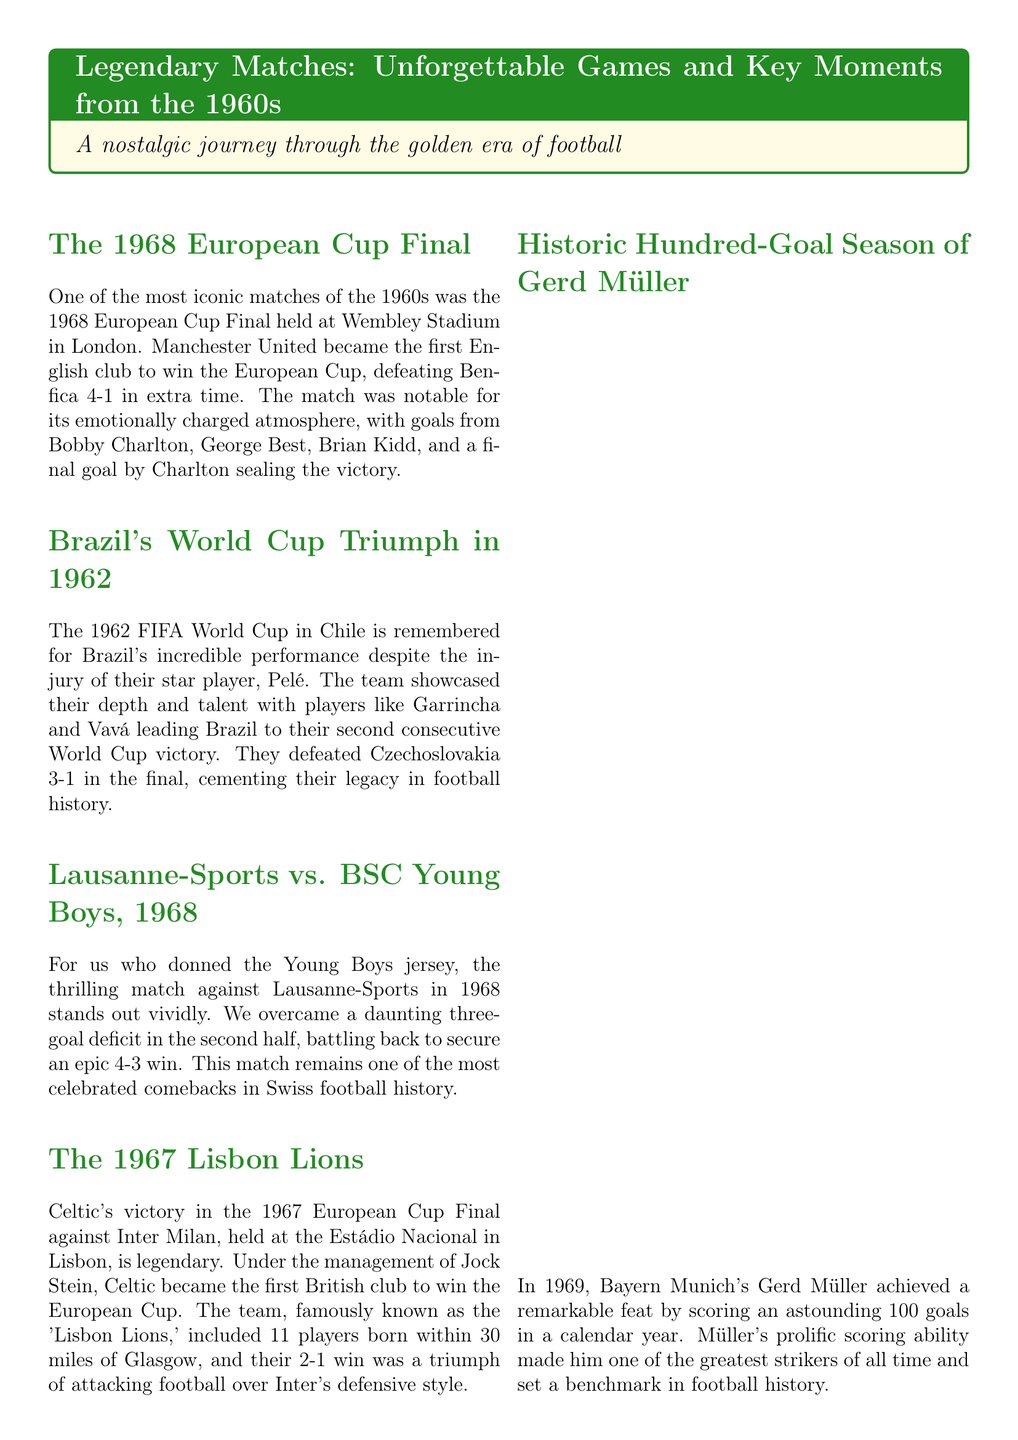What team won the 1968 European Cup Final? The document states that Manchester United won the 1968 European Cup Final against Benfica.
Answer: Manchester United What was the score of Brazil's World Cup final in 1962? Brazil won the final against Czechoslovakia with a score of 3-1.
Answer: 3-1 Who scored the final goal for Manchester United in the 1968 European Cup Final? The document indicates that Bobby Charlton scored the final goal for Manchester United in that match.
Answer: Bobby Charlton What remarkable feat did Gerd Müller achieve in 1969? Gerd Müller scored 100 goals in a calendar year, as mentioned in the document.
Answer: 100 goals Which club did the Lisbon Lions represent? The document notes that the team known as the 'Lisbon Lions' was Celtic Football Club.
Answer: Celtic What was the unique outcome of the Italy vs. Soviet Union match in 1968? The match was decided by a coin toss after a 0-0 draw, which is highlighted in the document.
Answer: Coin toss What city hosted the 1968 European Cup Final? According to the document, the final was held at Wembley Stadium in London.
Answer: London Who was the top scorer of the 1966 FIFA World Cup? The document states that Eusébio da Silva Ferreira was the top scorer, with nine goals.
Answer: Eusébio 